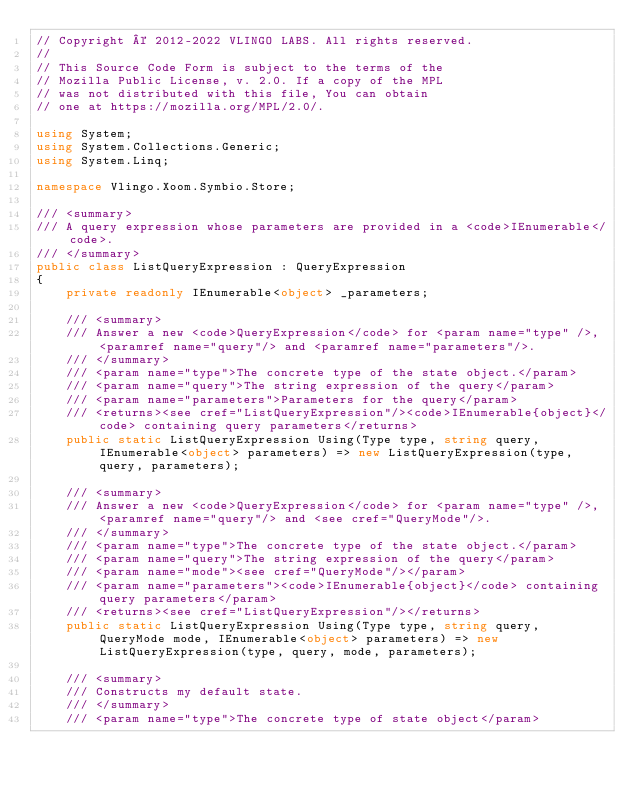Convert code to text. <code><loc_0><loc_0><loc_500><loc_500><_C#_>// Copyright © 2012-2022 VLINGO LABS. All rights reserved.
//
// This Source Code Form is subject to the terms of the
// Mozilla Public License, v. 2.0. If a copy of the MPL
// was not distributed with this file, You can obtain
// one at https://mozilla.org/MPL/2.0/.

using System;
using System.Collections.Generic;
using System.Linq;

namespace Vlingo.Xoom.Symbio.Store;

/// <summary>
/// A query expression whose parameters are provided in a <code>IEnumerable</code>.
/// </summary>
public class ListQueryExpression : QueryExpression
{
    private readonly IEnumerable<object> _parameters;

    /// <summary>
    /// Answer a new <code>QueryExpression</code> for <param name="type" />, <paramref name="query"/> and <paramref name="parameters"/>.
    /// </summary>
    /// <param name="type">The concrete type of the state object.</param>
    /// <param name="query">The string expression of the query</param>
    /// <param name="parameters">Parameters for the query</param>
    /// <returns><see cref="ListQueryExpression"/><code>IEnumerable{object}</code> containing query parameters</returns>
    public static ListQueryExpression Using(Type type, string query, IEnumerable<object> parameters) => new ListQueryExpression(type, query, parameters);

    /// <summary>
    /// Answer a new <code>QueryExpression</code> for <param name="type" />, <paramref name="query"/> and <see cref="QueryMode"/>.
    /// </summary>
    /// <param name="type">The concrete type of the state object.</param>
    /// <param name="query">The string expression of the query</param>
    /// <param name="mode"><see cref="QueryMode"/></param>
    /// <param name="parameters"><code>IEnumerable{object}</code> containing query parameters</param>
    /// <returns><see cref="ListQueryExpression"/></returns>
    public static ListQueryExpression Using(Type type, string query, QueryMode mode, IEnumerable<object> parameters) => new ListQueryExpression(type, query, mode, parameters);

    /// <summary>
    /// Constructs my default state.
    /// </summary>
    /// <param name="type">The concrete type of state object</param></code> 